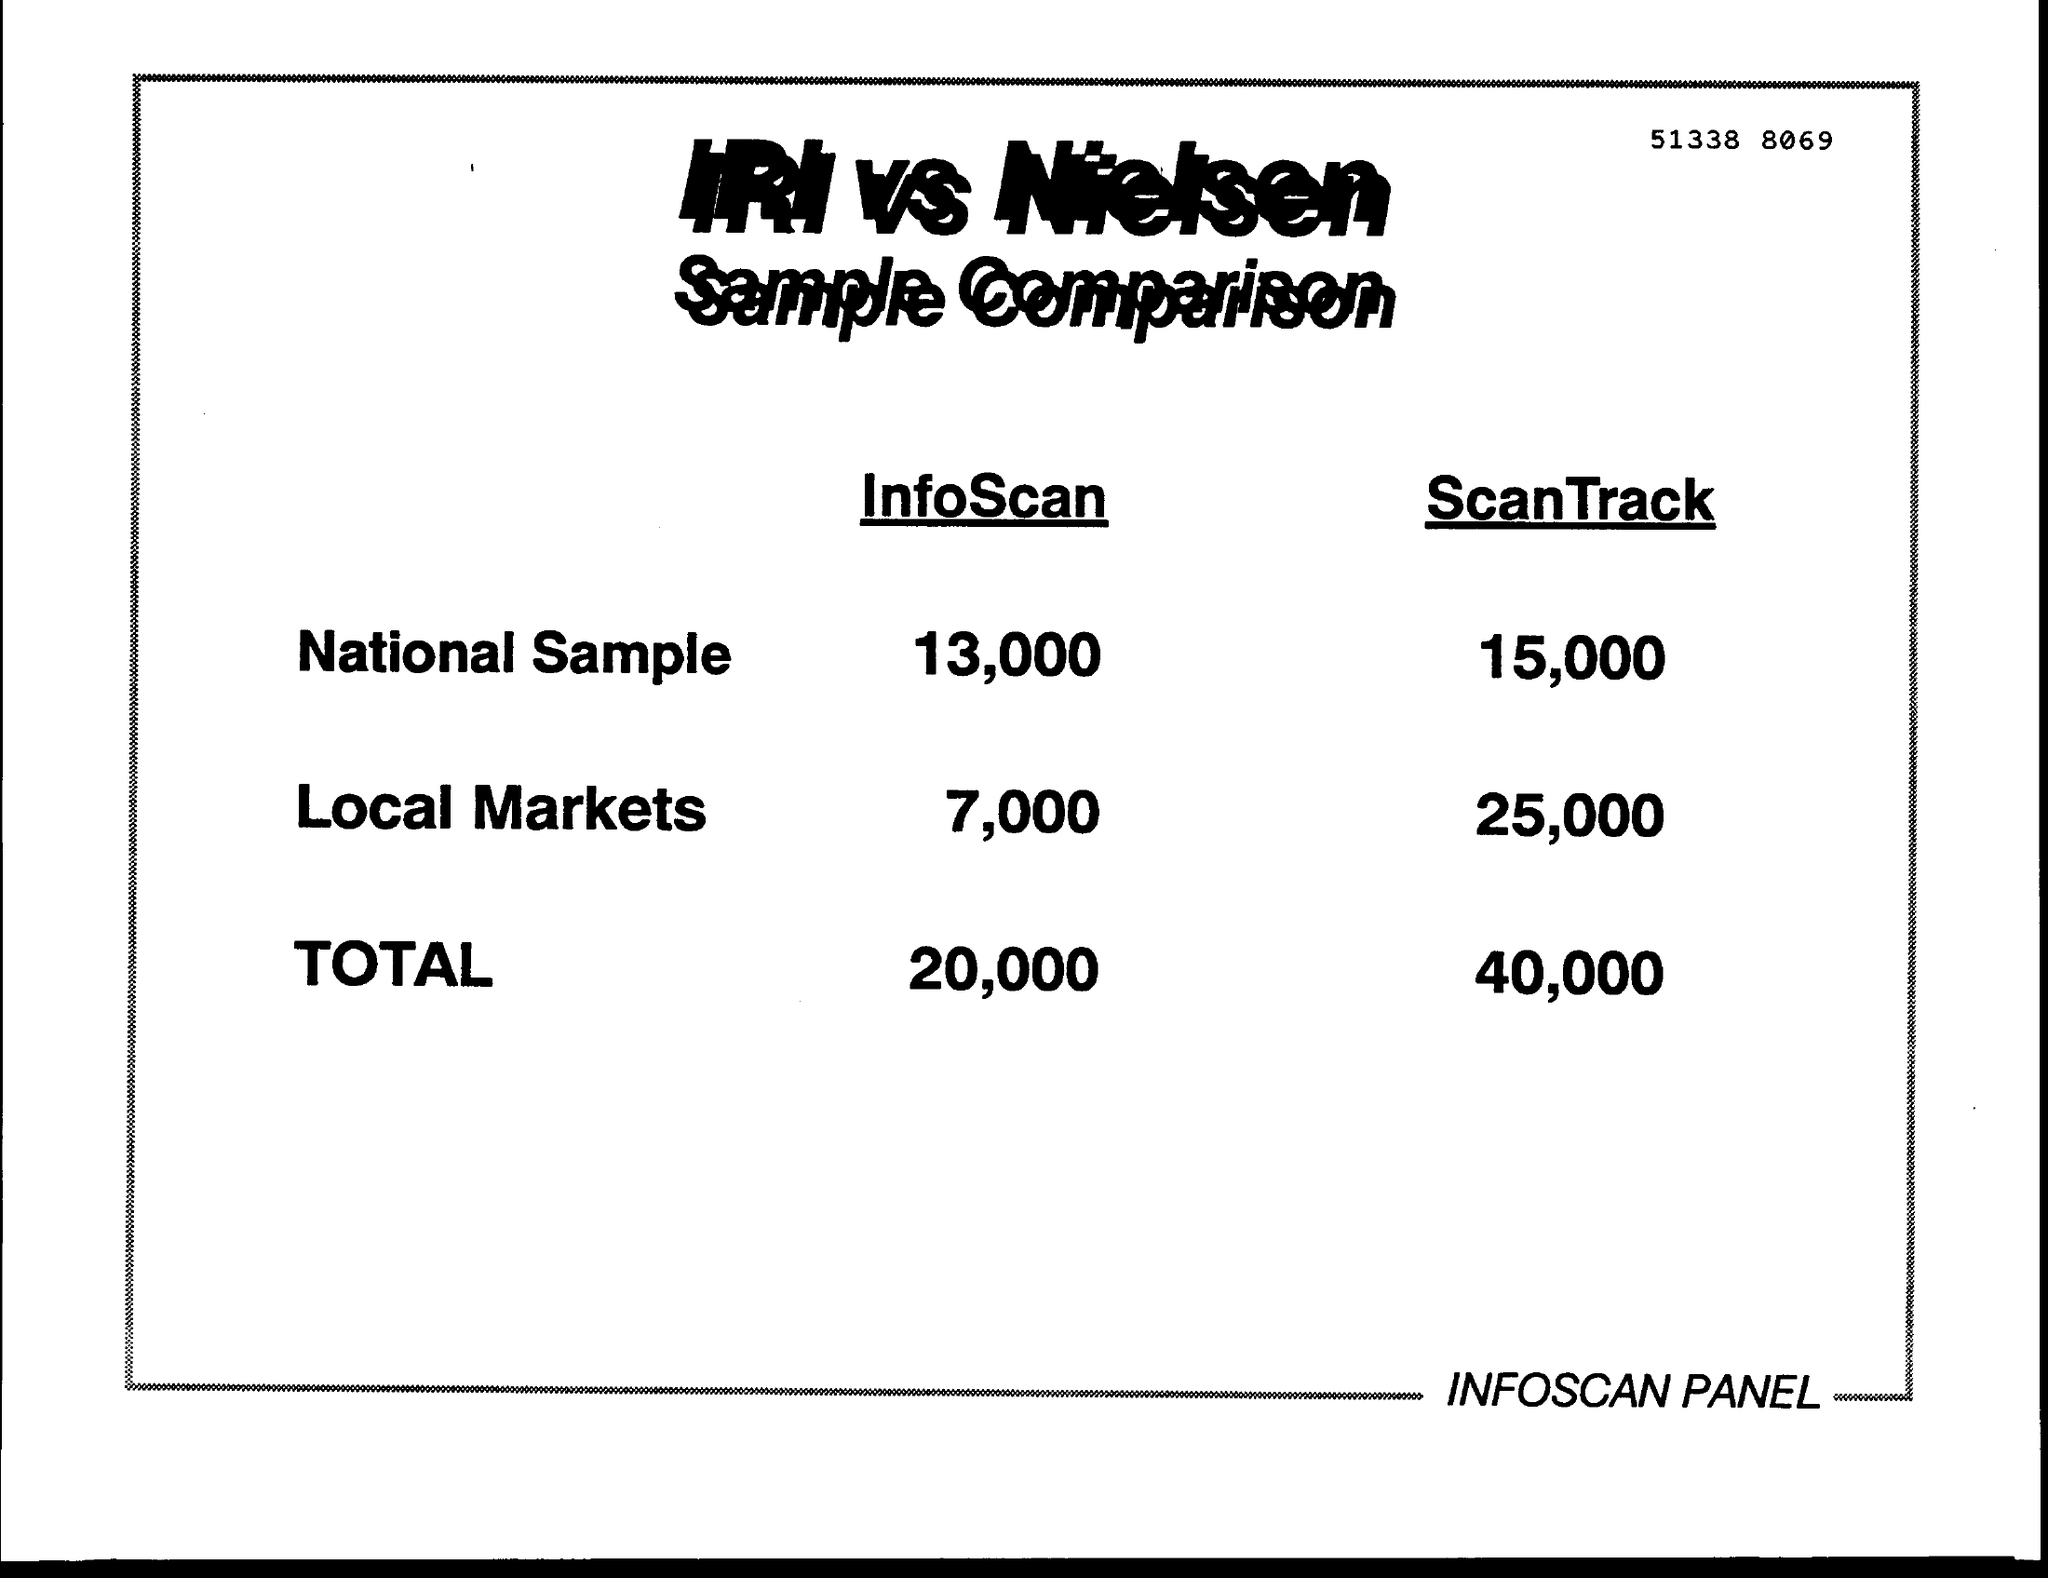What is the number written at the top of the page?
Offer a very short reply. 51338  8069. What is the InfoScan value of National Sample?
Offer a terse response. 13,000. What is the total value of ScanTrack?
Offer a terse response. 40,000. 